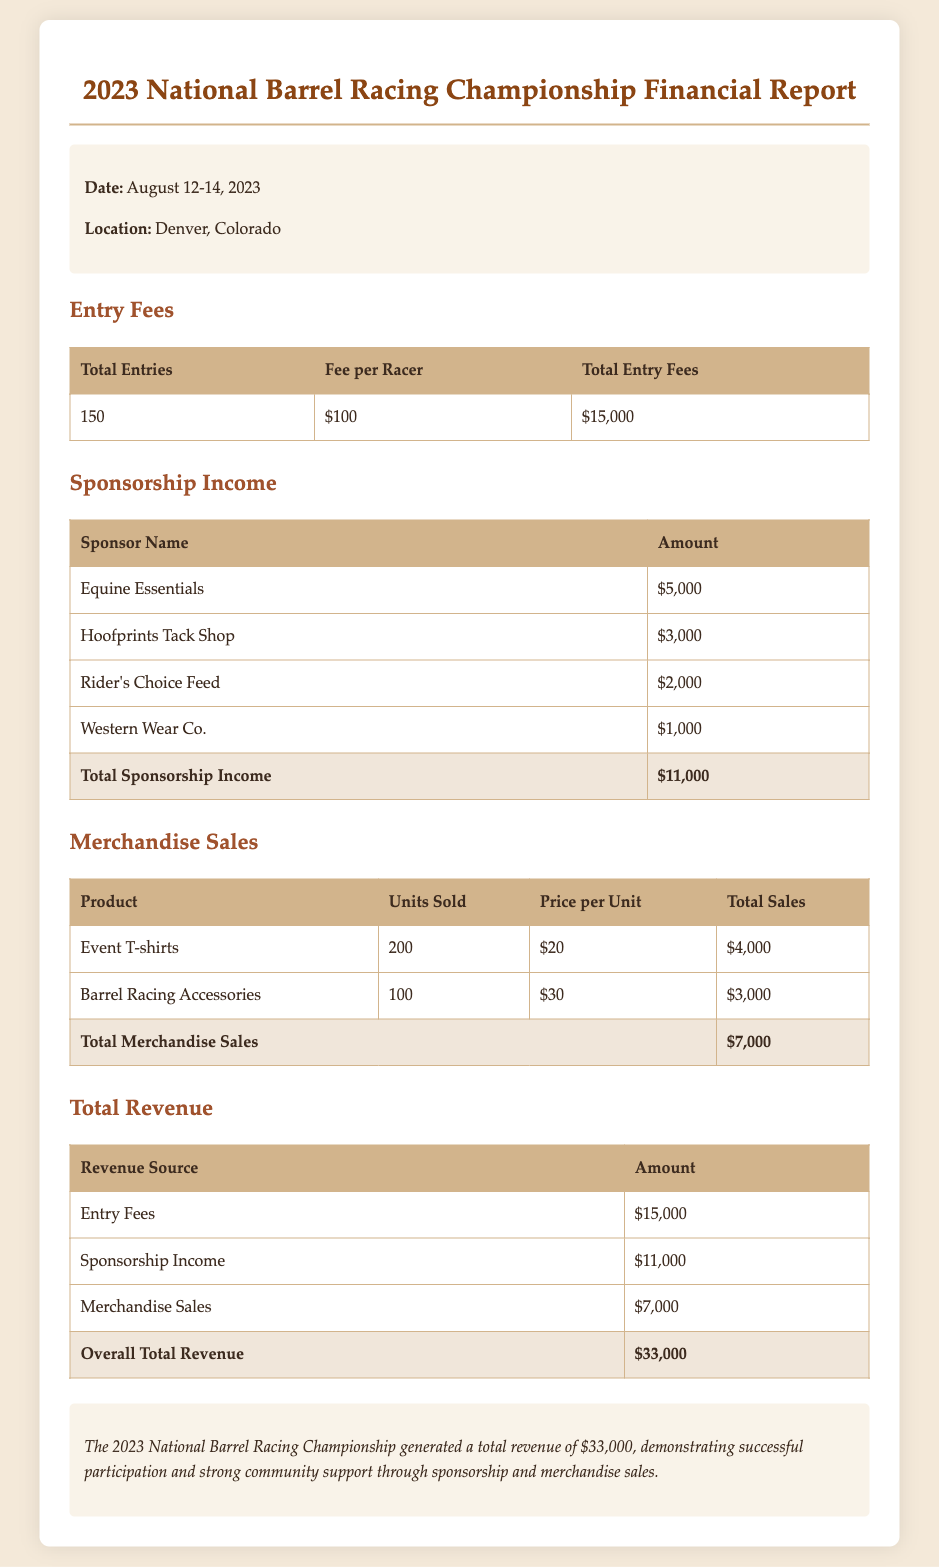What is the total number of entries? The total number of entries is specified in the Entry Fees section of the document, which states there were 150 entries.
Answer: 150 What was the fee per racer? The fee per racer is found in the Entry Fees section of the document, listed as $100.
Answer: $100 What is the total sponsorship income? The total sponsorship income is calculated by summing the individual sponsorship amounts listed, which totals $11,000.
Answer: $11,000 How many event t-shirts were sold? The number of event t-shirts sold is detailed in the Merchandise Sales section, stating that 200 units were sold.
Answer: 200 What is the overall total revenue? The overall total revenue is provided in the Total Revenue section, which sums up all sources to $33,000.
Answer: $33,000 Which sponsor contributed the least amount? The sponsor contributing the least is mentioned in the Sponsorship Income section, identified as Western Wear Co. with an amount of $1,000.
Answer: Western Wear Co What was the total revenue from merchandise sales? The total revenue from merchandise sales is given in the Merchandise Sales section, calculated as $7,000.
Answer: $7,000 How much did Rider's Choice Feed contribute? The contribution from Rider's Choice Feed is itemized in the Sponsorship Income section, amounting to $2,000.
Answer: $2,000 How many barrel racing accessories were sold? The amount of barrel racing accessories sold is stated in the Merchandise Sales section, totaling 100 units.
Answer: 100 